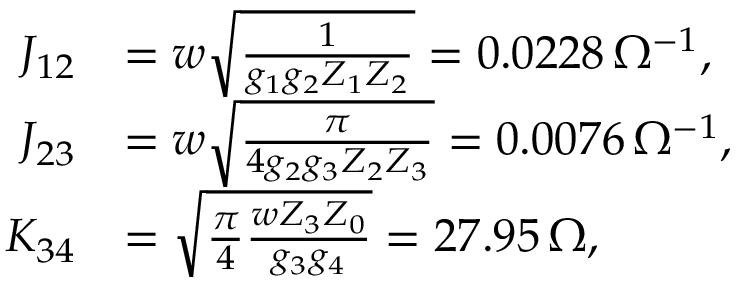Convert formula to latex. <formula><loc_0><loc_0><loc_500><loc_500>\begin{array} { r l } { J _ { 1 2 } } & { = w \sqrt { \frac { 1 } { g _ { 1 } g _ { 2 } Z _ { 1 } Z _ { 2 } } } = 0 . 0 2 2 8 \, \Omega ^ { - 1 } , } \\ { J _ { 2 3 } } & { = w \sqrt { \frac { \pi } { 4 g _ { 2 } g _ { 3 } Z _ { 2 } Z _ { 3 } } } = 0 . 0 0 7 6 \, \Omega ^ { - 1 } , } \\ { K _ { 3 4 } } & { = \sqrt { \frac { \pi } { 4 } \frac { w Z _ { 3 } Z _ { 0 } } { g _ { 3 } g _ { 4 } } } = 2 7 . 9 5 \, \Omega , } \end{array}</formula> 